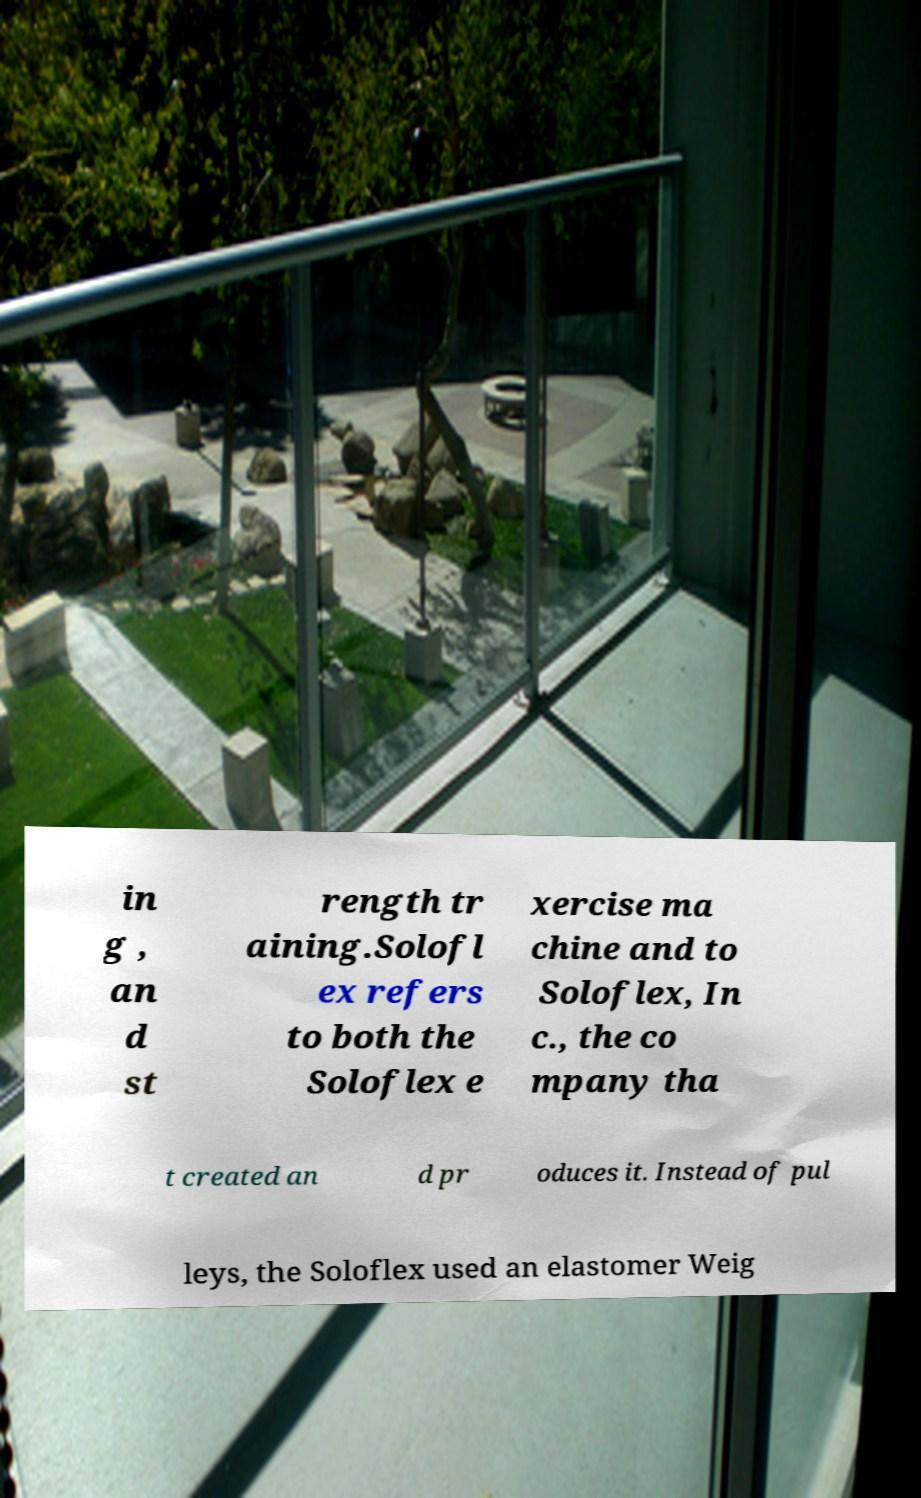Can you read and provide the text displayed in the image?This photo seems to have some interesting text. Can you extract and type it out for me? in g , an d st rength tr aining.Solofl ex refers to both the Soloflex e xercise ma chine and to Soloflex, In c., the co mpany tha t created an d pr oduces it. Instead of pul leys, the Soloflex used an elastomer Weig 